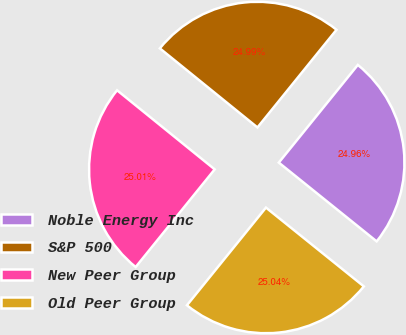<chart> <loc_0><loc_0><loc_500><loc_500><pie_chart><fcel>Noble Energy Inc<fcel>S&P 500<fcel>New Peer Group<fcel>Old Peer Group<nl><fcel>24.96%<fcel>24.99%<fcel>25.01%<fcel>25.04%<nl></chart> 